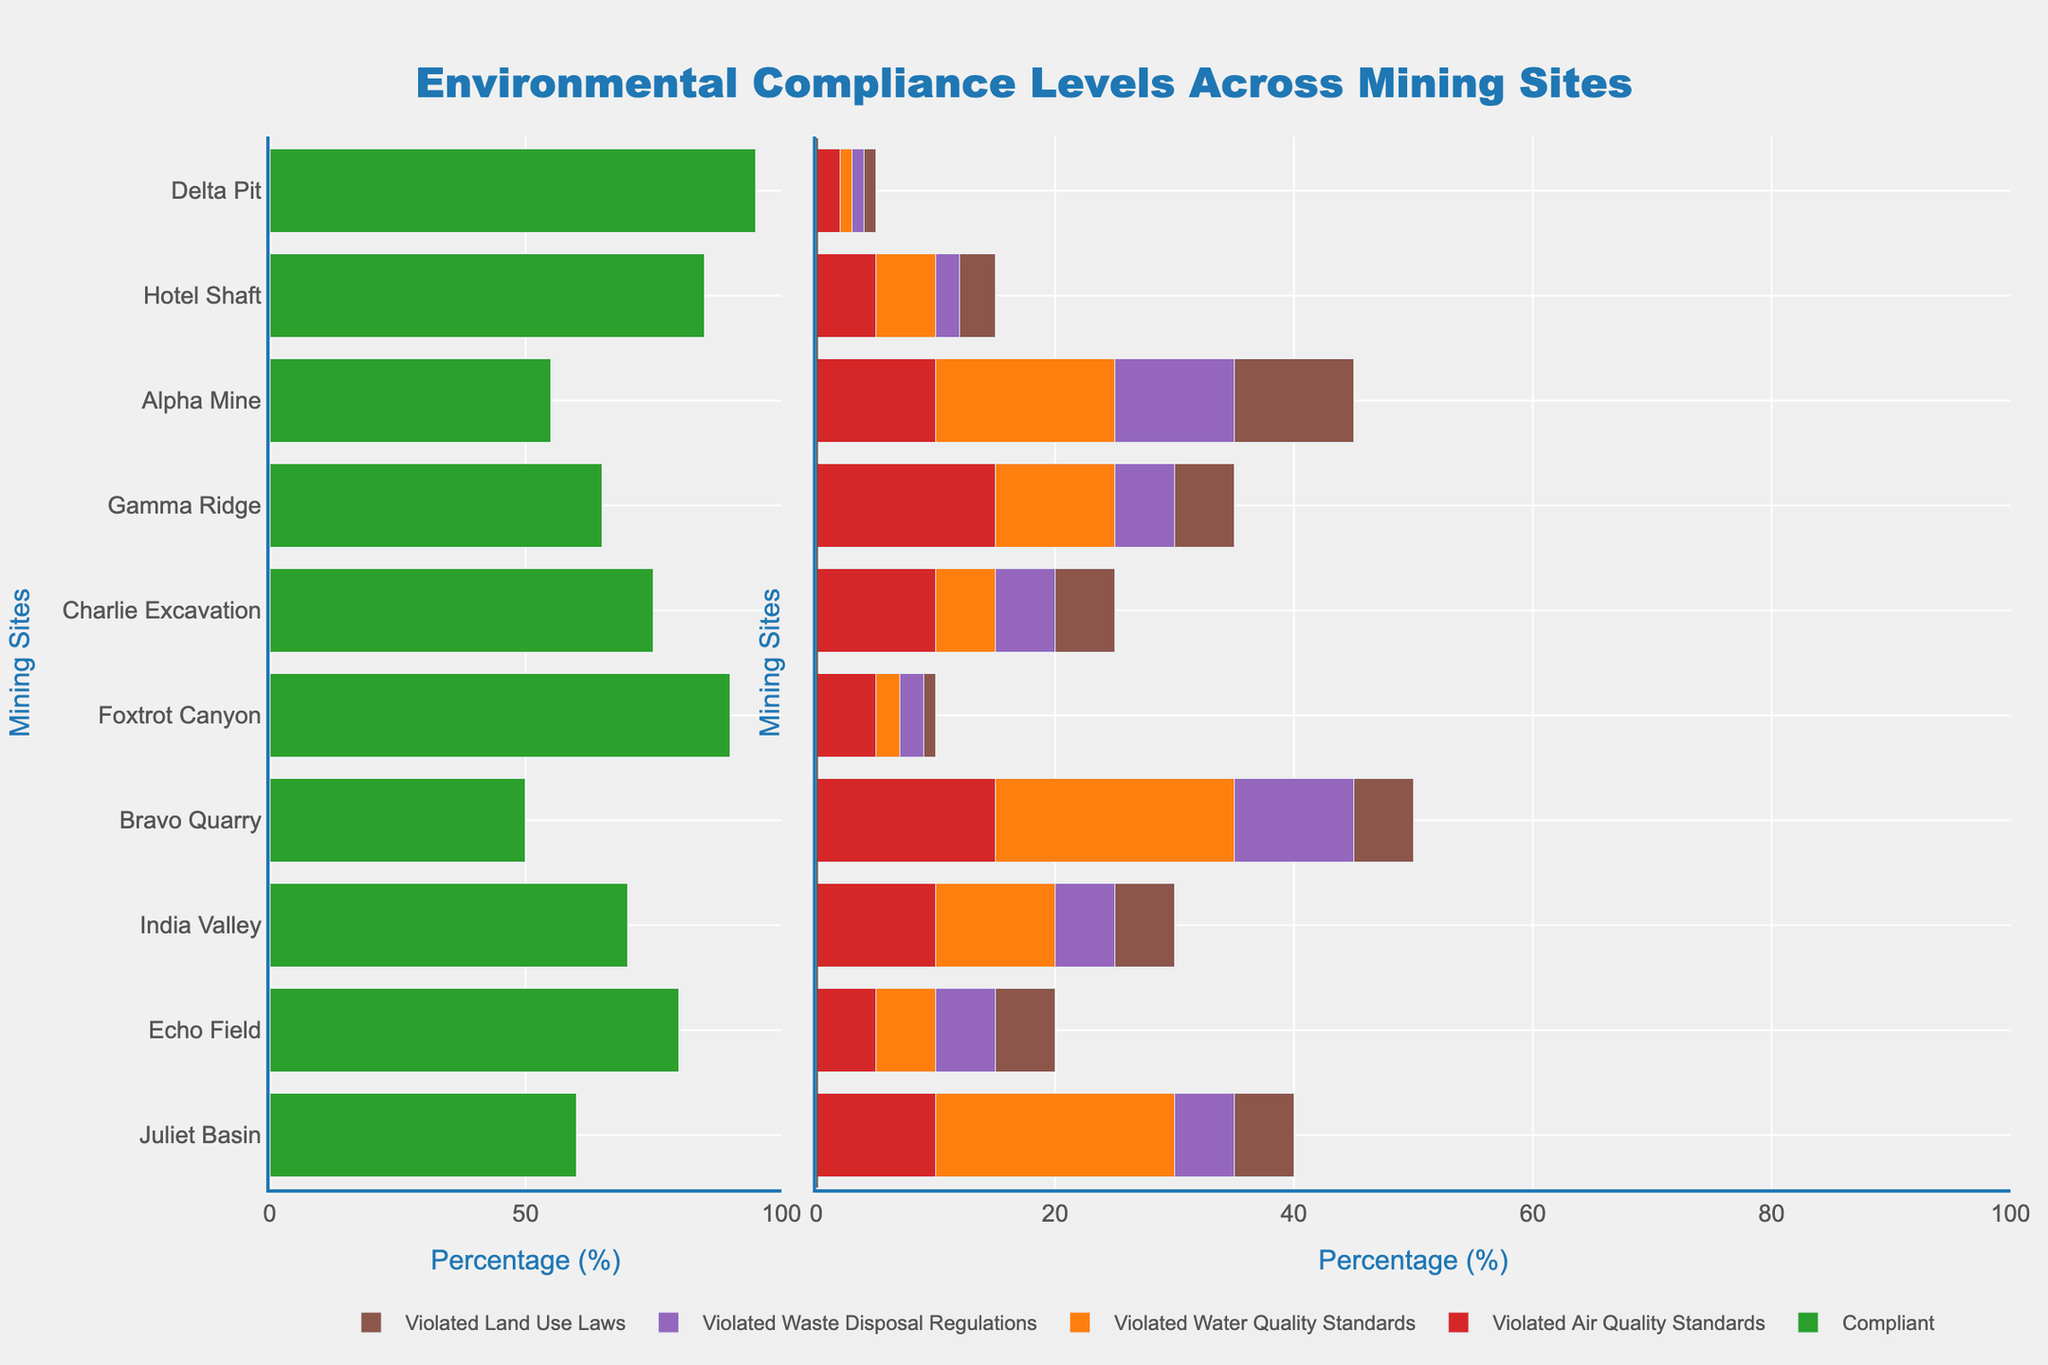What's the mining site with the highest compliance level? First, locate the green bars representing compliance levels, then identify the site with the longest green bar. "Juliet Basin" has the longest green bar, leading to its highest compliance level.
Answer: Juliet Basin Which mining site has the highest number of violated water quality standards? Find the orange bars corresponding to "Violated Water Quality Standards". The site with the longest orange bar indicates the highest number. "Delta Pit" has the longest orange bar.
Answer: Delta Pit What's the total percentage of violations (all types) at Bravo Quarry? Sum the percentages of all violation types for "Bravo Quarry" (5 + 5 + 5 + 5). The total is 5+5+5+5=20%.
Answer: 20% Which mining site has the closest compliance level to Foxtrot Canyon? Identify the compliance level of "Foxtrot Canyon" (75%), then find the site with a compliance level nearest to this value. "Charlie Excavation" has a compliance level of 70%, which is closest.
Answer: Charlie Excavation Compare Alpha Mine and Hotel Shaft in terms of land use law violations. Which has a higher violation level? Look at the brown bars representing "Violated Land Use Laws" for "Alpha Mine" (5%) and "Hotel Shaft" (10%). "Hotel Shaft" has a higher percentage.
Answer: Hotel Shaft What is the average compliance level across all mining sites? Add up the compliance levels of all sites and divide by the number of sites: (60+80+70+50+90+75+65+55+85+95)/10. The total is 725/10 = 72.5%.
Answer: 72.5% How many mining sites have compliance levels above 80%? Identify bars greater than 80%: "Bravo Quarry" (80%), "Echo Field" (90%), "India Valley" (85%), "Juliet Basin" (95%). Count these sites. There are 4 sites.
Answer: 4 Which violation type is most common at Charlie Excavation? Compare the lengths of different-colored bars at "Charlie Excavation". The longest bar is orange, representing "Violated Water Quality Standards" (10%).
Answer: Violated Water Quality Standards What's the difference in compliance levels between Echo Field and Delta Pit? Subtract the compliance percentage of "Delta Pit" (50%) from that of "Echo Field" (90%). The difference is 90% - 50% = 40%.
Answer: 40% Compare air quality standards violations between Foxtrot Canyon and Gamma Ridge. Which has more violations? Look at the red bars for "Violated Air Quality Standards" in both sites. Both have 10%.
Answer: Equal 